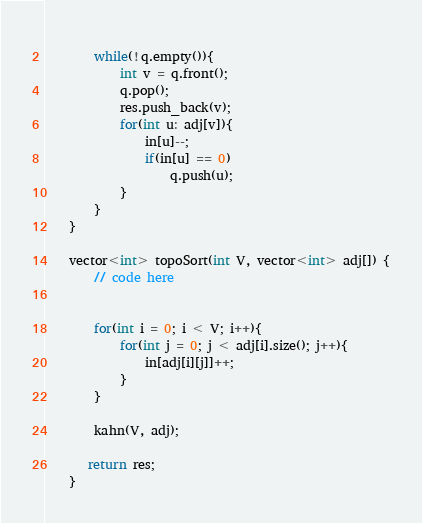<code> <loc_0><loc_0><loc_500><loc_500><_C++_>	    
	    while(!q.empty()){
	        int v = q.front();
	        q.pop();
	        res.push_back(v);
	        for(int u: adj[v]){
	            in[u]--;
	            if(in[u] == 0)
	                q.push(u);
	        }
	    }
	}
	
	vector<int> topoSort(int V, vector<int> adj[]) {
	    // code here
	    
	 
	    for(int i = 0; i < V; i++){
	        for(int j = 0; j < adj[i].size(); j++){
	            in[adj[i][j]]++;
	        }
	    }
	    
	    kahn(V, adj);
	    
	   return res;
	}
</code> 